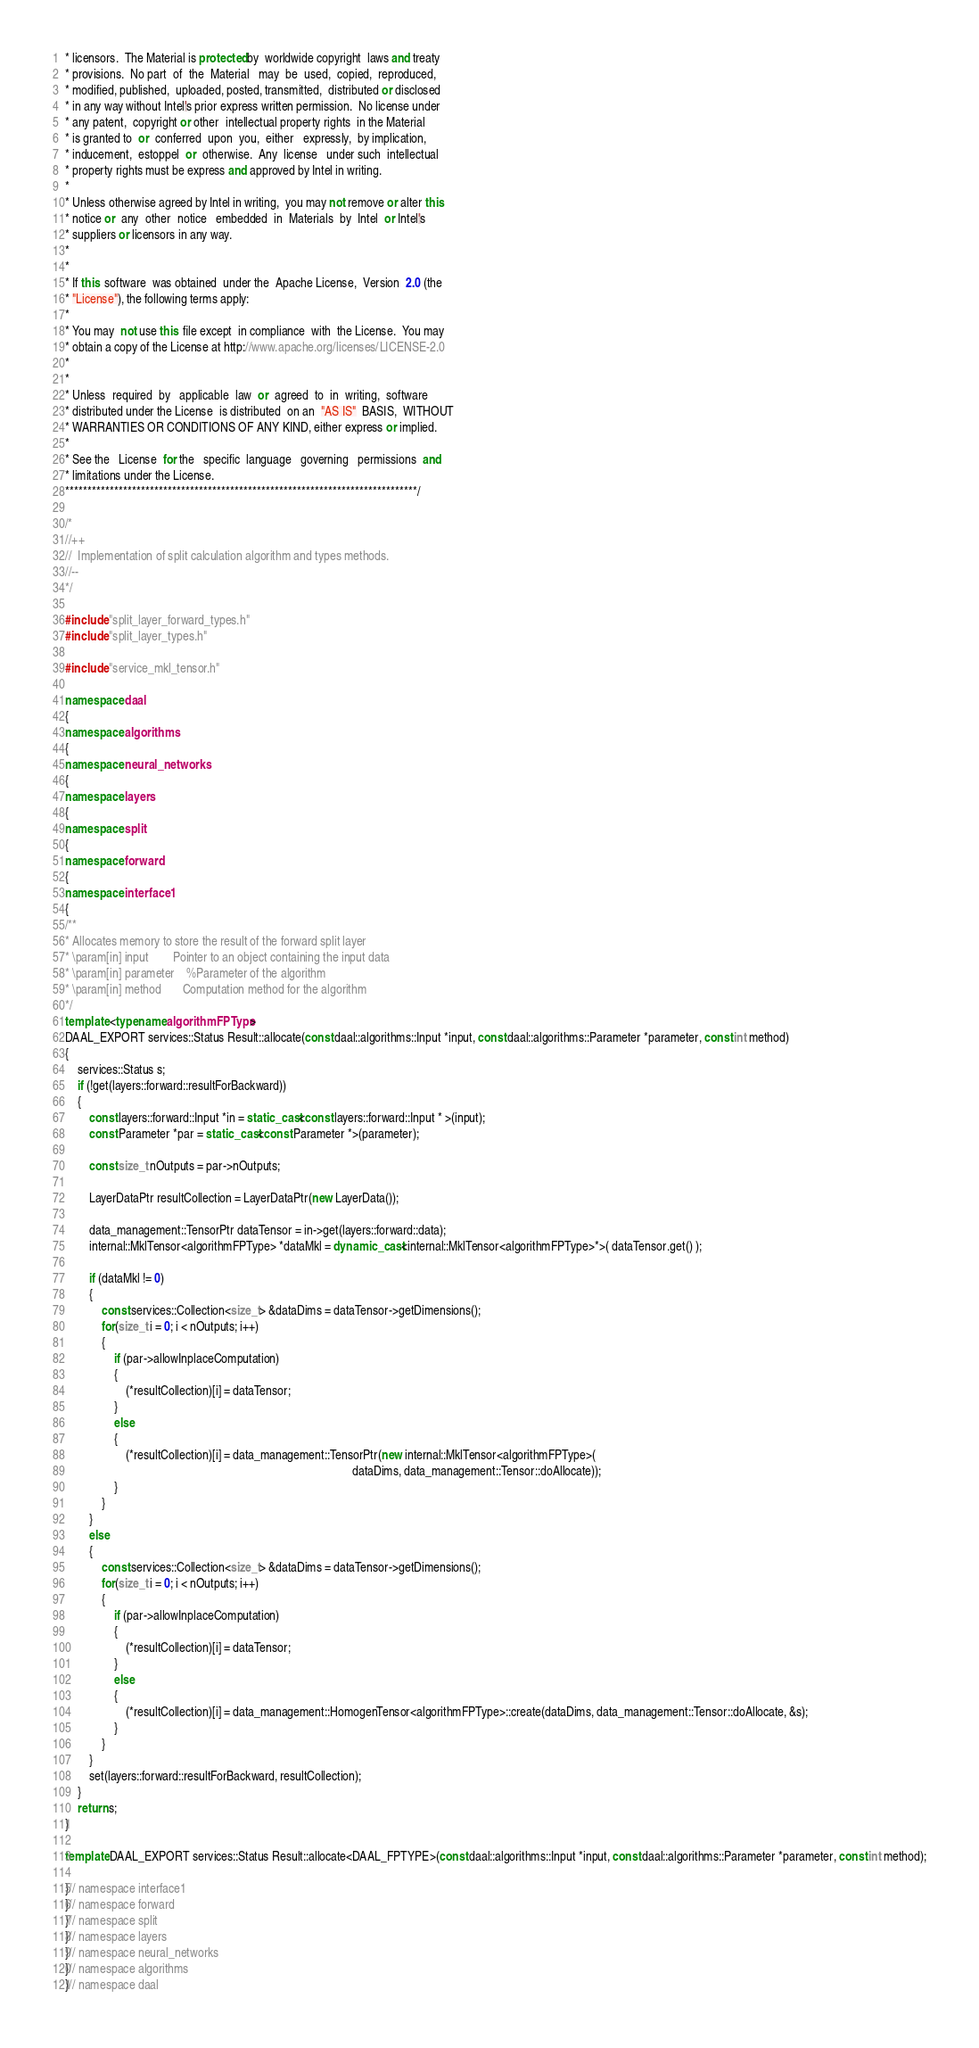Convert code to text. <code><loc_0><loc_0><loc_500><loc_500><_C++_>* licensors.  The Material is protected by  worldwide copyright  laws and treaty
* provisions.  No part  of  the  Material   may  be  used,  copied,  reproduced,
* modified, published,  uploaded, posted, transmitted,  distributed or disclosed
* in any way without Intel's prior express written permission.  No license under
* any patent,  copyright or other  intellectual property rights  in the Material
* is granted to  or  conferred  upon  you,  either   expressly,  by implication,
* inducement,  estoppel  or  otherwise.  Any  license   under such  intellectual
* property rights must be express and approved by Intel in writing.
*
* Unless otherwise agreed by Intel in writing,  you may not remove or alter this
* notice or  any  other  notice   embedded  in  Materials  by  Intel  or Intel's
* suppliers or licensors in any way.
*
*
* If this  software  was obtained  under the  Apache License,  Version  2.0 (the
* "License"), the following terms apply:
*
* You may  not use this  file except  in compliance  with  the License.  You may
* obtain a copy of the License at http://www.apache.org/licenses/LICENSE-2.0
*
*
* Unless  required  by   applicable  law  or  agreed  to  in  writing,  software
* distributed under the License  is distributed  on an  "AS IS"  BASIS,  WITHOUT
* WARRANTIES OR CONDITIONS OF ANY KIND, either express or implied.
*
* See the   License  for the   specific  language   governing   permissions  and
* limitations under the License.
*******************************************************************************/

/*
//++
//  Implementation of split calculation algorithm and types methods.
//--
*/

#include "split_layer_forward_types.h"
#include "split_layer_types.h"

#include "service_mkl_tensor.h"

namespace daal
{
namespace algorithms
{
namespace neural_networks
{
namespace layers
{
namespace split
{
namespace forward
{
namespace interface1
{
/**
* Allocates memory to store the result of the forward split layer
* \param[in] input        Pointer to an object containing the input data
* \param[in] parameter    %Parameter of the algorithm
* \param[in] method       Computation method for the algorithm
*/
template <typename algorithmFPType>
DAAL_EXPORT services::Status Result::allocate(const daal::algorithms::Input *input, const daal::algorithms::Parameter *parameter, const int method)
{
    services::Status s;
    if (!get(layers::forward::resultForBackward))
    {
        const layers::forward::Input *in = static_cast<const layers::forward::Input * >(input);
        const Parameter *par = static_cast<const Parameter *>(parameter);

        const size_t nOutputs = par->nOutputs;

        LayerDataPtr resultCollection = LayerDataPtr(new LayerData());

        data_management::TensorPtr dataTensor = in->get(layers::forward::data);
        internal::MklTensor<algorithmFPType> *dataMkl = dynamic_cast<internal::MklTensor<algorithmFPType>*>( dataTensor.get() );

        if (dataMkl != 0)
        {
            const services::Collection<size_t> &dataDims = dataTensor->getDimensions();
            for(size_t i = 0; i < nOutputs; i++)
            {
                if (par->allowInplaceComputation)
                {
                    (*resultCollection)[i] = dataTensor;
                }
                else
                {
                    (*resultCollection)[i] = data_management::TensorPtr(new internal::MklTensor<algorithmFPType>(
                                                                                              dataDims, data_management::Tensor::doAllocate));
                }
            }
        }
        else
        {
            const services::Collection<size_t> &dataDims = dataTensor->getDimensions();
            for(size_t i = 0; i < nOutputs; i++)
            {
                if (par->allowInplaceComputation)
                {
                    (*resultCollection)[i] = dataTensor;
                }
                else
                {
                    (*resultCollection)[i] = data_management::HomogenTensor<algorithmFPType>::create(dataDims, data_management::Tensor::doAllocate, &s);
                }
            }
        }
        set(layers::forward::resultForBackward, resultCollection);
    }
    return s;
}

template DAAL_EXPORT services::Status Result::allocate<DAAL_FPTYPE>(const daal::algorithms::Input *input, const daal::algorithms::Parameter *parameter, const int method);

}// namespace interface1
}// namespace forward
}// namespace split
}// namespace layers
}// namespace neural_networks
}// namespace algorithms
}// namespace daal
</code> 